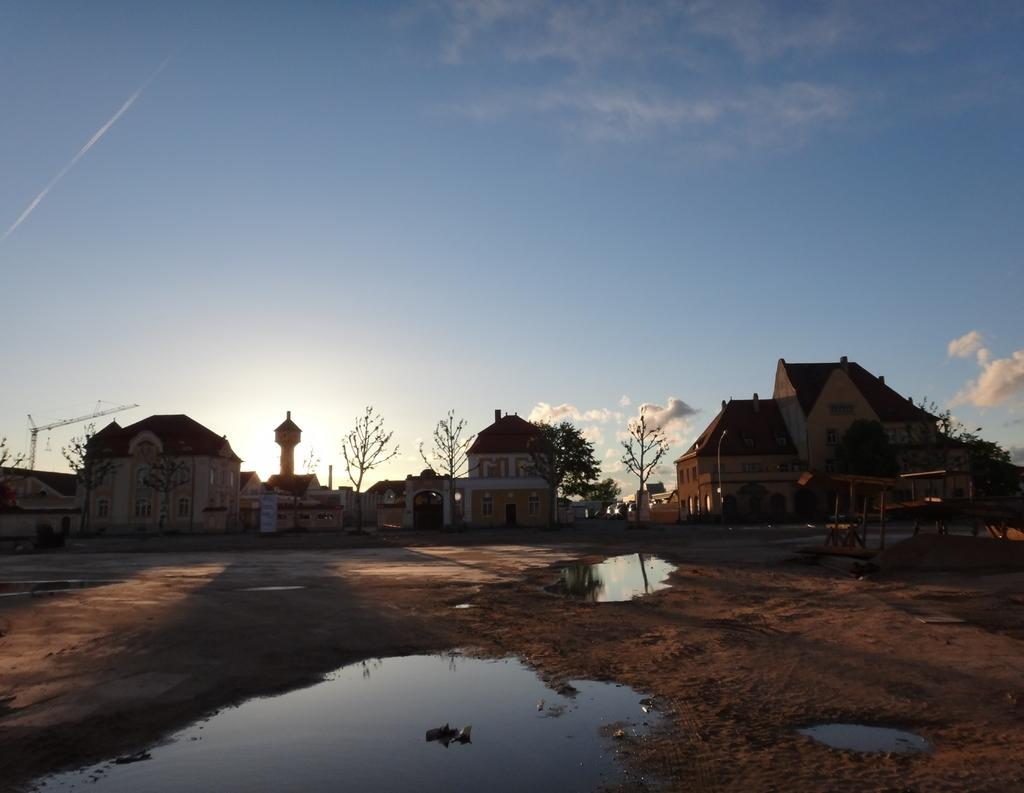What type of structures can be seen in the image? There are houses and a tower visible in the image. What natural elements are present in the image? There are trees and water visible in the image. What architectural features can be observed in the image? There are walls and windows visible in the image. What construction equipment is present in the image? There is a crane visible in the image. What type of surface is visible in the image? There is ground visible in the image. What part of the natural environment is visible in the background of the image? The sky is visible in the background of the image. Can you hear the ear in the image? There is no ear present in the image; it is a visual representation. What type of print can be seen on the ground in the image? There is no print visible on the ground in the image. 